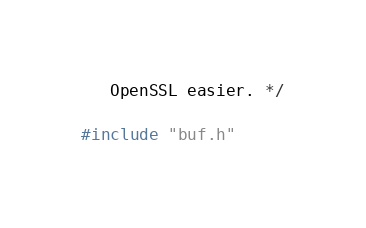<code> <loc_0><loc_0><loc_500><loc_500><_C_>   OpenSSL easier. */

#include "buf.h"
</code> 